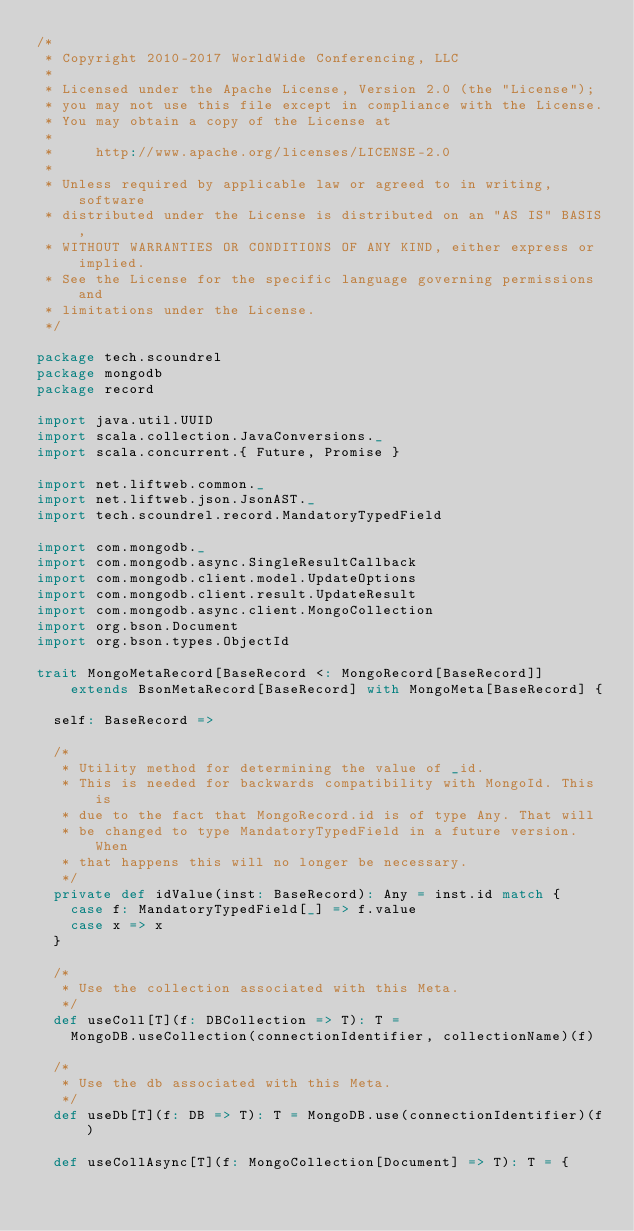<code> <loc_0><loc_0><loc_500><loc_500><_Scala_>/*
 * Copyright 2010-2017 WorldWide Conferencing, LLC
 *
 * Licensed under the Apache License, Version 2.0 (the "License");
 * you may not use this file except in compliance with the License.
 * You may obtain a copy of the License at
 *
 *     http://www.apache.org/licenses/LICENSE-2.0
 *
 * Unless required by applicable law or agreed to in writing, software
 * distributed under the License is distributed on an "AS IS" BASIS,
 * WITHOUT WARRANTIES OR CONDITIONS OF ANY KIND, either express or implied.
 * See the License for the specific language governing permissions and
 * limitations under the License.
 */

package tech.scoundrel
package mongodb
package record

import java.util.UUID
import scala.collection.JavaConversions._
import scala.concurrent.{ Future, Promise }

import net.liftweb.common._
import net.liftweb.json.JsonAST._
import tech.scoundrel.record.MandatoryTypedField

import com.mongodb._
import com.mongodb.async.SingleResultCallback
import com.mongodb.client.model.UpdateOptions
import com.mongodb.client.result.UpdateResult
import com.mongodb.async.client.MongoCollection
import org.bson.Document
import org.bson.types.ObjectId

trait MongoMetaRecord[BaseRecord <: MongoRecord[BaseRecord]]
    extends BsonMetaRecord[BaseRecord] with MongoMeta[BaseRecord] {

  self: BaseRecord =>

  /*
   * Utility method for determining the value of _id.
   * This is needed for backwards compatibility with MongoId. This is
   * due to the fact that MongoRecord.id is of type Any. That will
   * be changed to type MandatoryTypedField in a future version. When
   * that happens this will no longer be necessary.
   */
  private def idValue(inst: BaseRecord): Any = inst.id match {
    case f: MandatoryTypedField[_] => f.value
    case x => x
  }

  /*
   * Use the collection associated with this Meta.
   */
  def useColl[T](f: DBCollection => T): T =
    MongoDB.useCollection(connectionIdentifier, collectionName)(f)

  /*
   * Use the db associated with this Meta.
   */
  def useDb[T](f: DB => T): T = MongoDB.use(connectionIdentifier)(f)

  def useCollAsync[T](f: MongoCollection[Document] => T): T = {</code> 